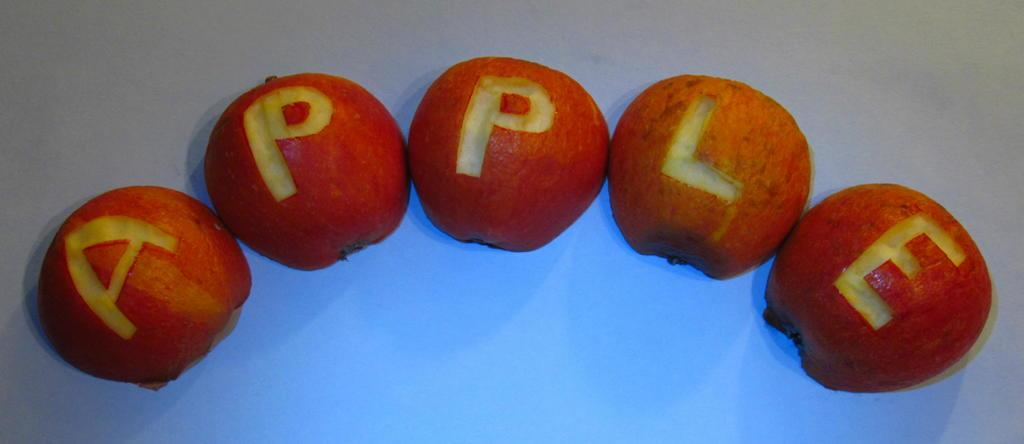What type of fruit is present in the image? There are apples in the image. What is unique about the appearance of the apples? The apples have carvings on them. Where are the apples located in the image? The apples are placed on a surface. What type of crime is being committed in the image? There is no crime present in the image; it features apples with carvings on them. What type of discovery is being made in the image? There is no discovery being made in the image; it features apples with carvings on them. 